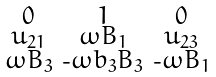<formula> <loc_0><loc_0><loc_500><loc_500>\begin{smallmatrix} 0 & 1 & 0 \\ u _ { 2 1 } & \omega B _ { 1 } & u _ { 2 3 } \\ \omega B _ { 3 } & \text {-} \omega b _ { 3 } B _ { 3 } & \text {-} \omega B _ { 1 } \end{smallmatrix}</formula> 